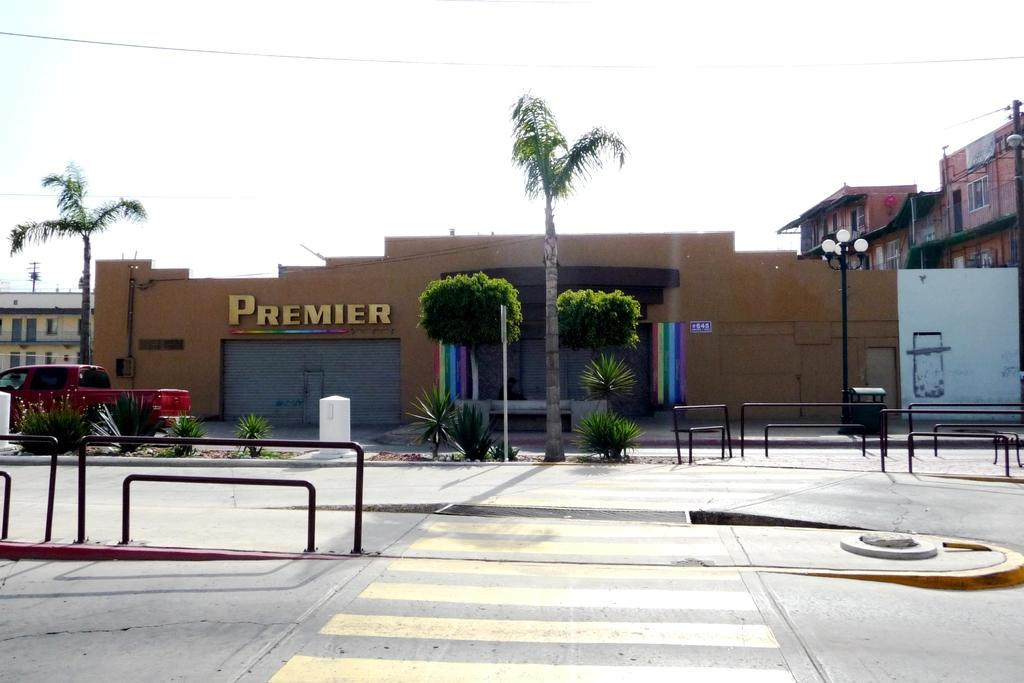What is the main feature in the center of the image? There is a road in the center of the image. What structures are present alongside the road? There are barrier gates in the image. What can be seen in the background of the image? There is a building and trees in the background of the image. Is there any vehicle visible in the image? Yes, there is a vehicle on the road. How many knees can be seen in the image? There are no knees visible in the image. What type of wash is being performed on the vehicle in the image? There is no vehicle wash taking place in the image; it only shows a vehicle on the road. 